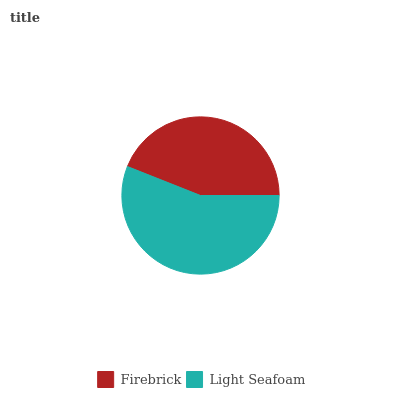Is Firebrick the minimum?
Answer yes or no. Yes. Is Light Seafoam the maximum?
Answer yes or no. Yes. Is Light Seafoam the minimum?
Answer yes or no. No. Is Light Seafoam greater than Firebrick?
Answer yes or no. Yes. Is Firebrick less than Light Seafoam?
Answer yes or no. Yes. Is Firebrick greater than Light Seafoam?
Answer yes or no. No. Is Light Seafoam less than Firebrick?
Answer yes or no. No. Is Light Seafoam the high median?
Answer yes or no. Yes. Is Firebrick the low median?
Answer yes or no. Yes. Is Firebrick the high median?
Answer yes or no. No. Is Light Seafoam the low median?
Answer yes or no. No. 